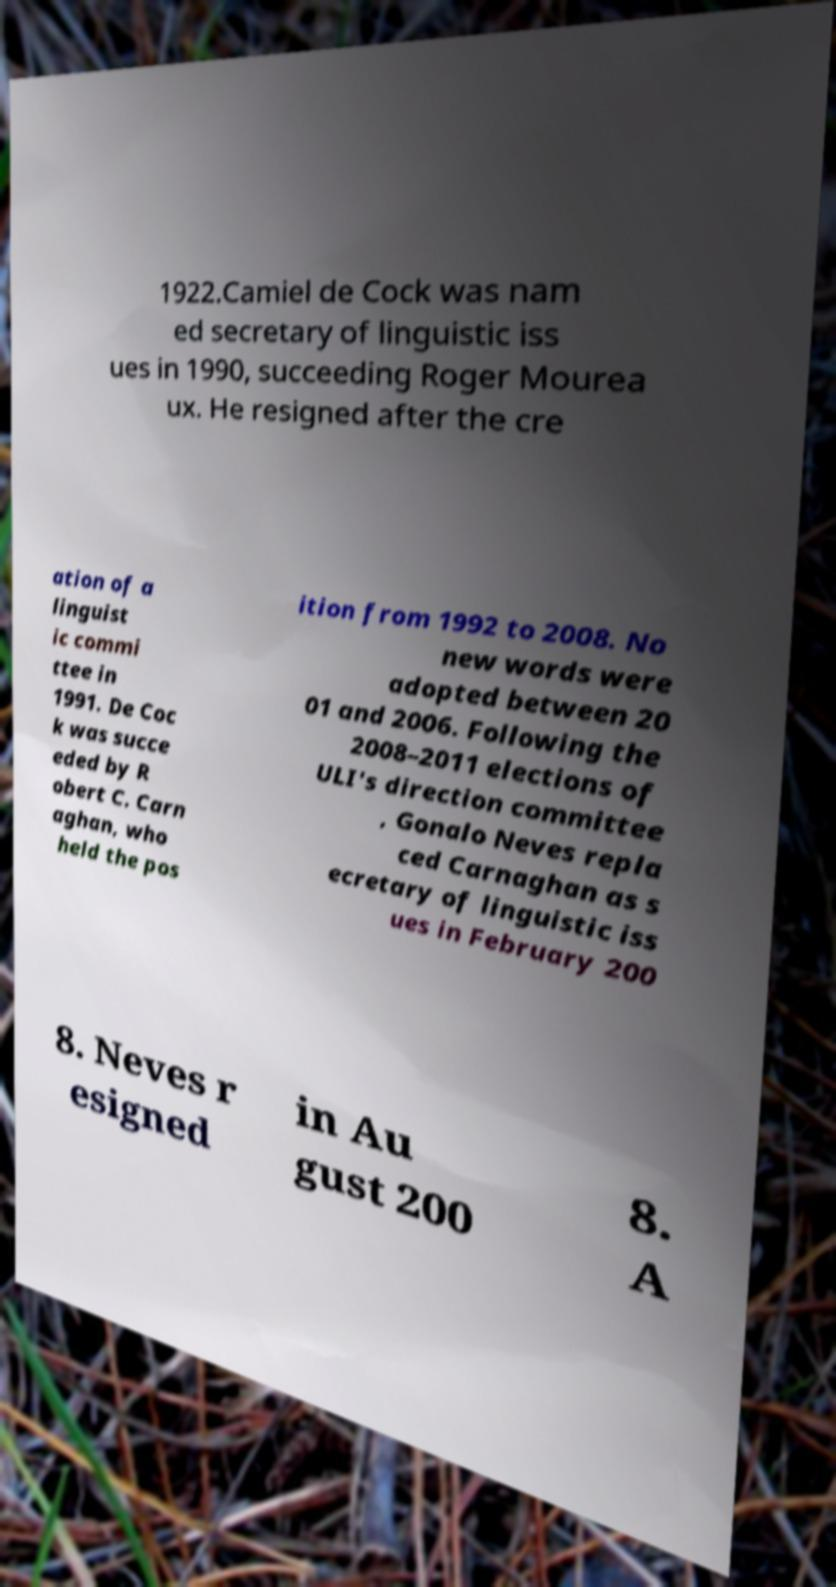Could you assist in decoding the text presented in this image and type it out clearly? 1922.Camiel de Cock was nam ed secretary of linguistic iss ues in 1990, succeeding Roger Mourea ux. He resigned after the cre ation of a linguist ic commi ttee in 1991. De Coc k was succe eded by R obert C. Carn aghan, who held the pos ition from 1992 to 2008. No new words were adopted between 20 01 and 2006. Following the 2008–2011 elections of ULI's direction committee , Gonalo Neves repla ced Carnaghan as s ecretary of linguistic iss ues in February 200 8. Neves r esigned in Au gust 200 8. A 